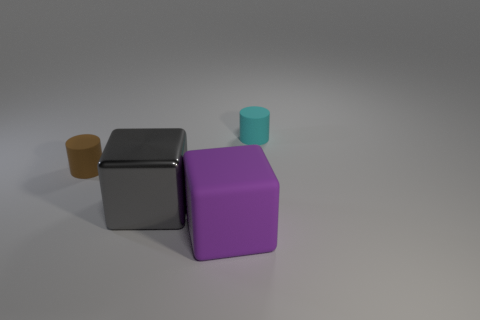Add 4 tiny brown things. How many objects exist? 8 Add 3 tiny cyan things. How many tiny cyan things exist? 4 Subtract 0 gray balls. How many objects are left? 4 Subtract all purple metallic cubes. Subtract all large gray metallic blocks. How many objects are left? 3 Add 2 metal cubes. How many metal cubes are left? 3 